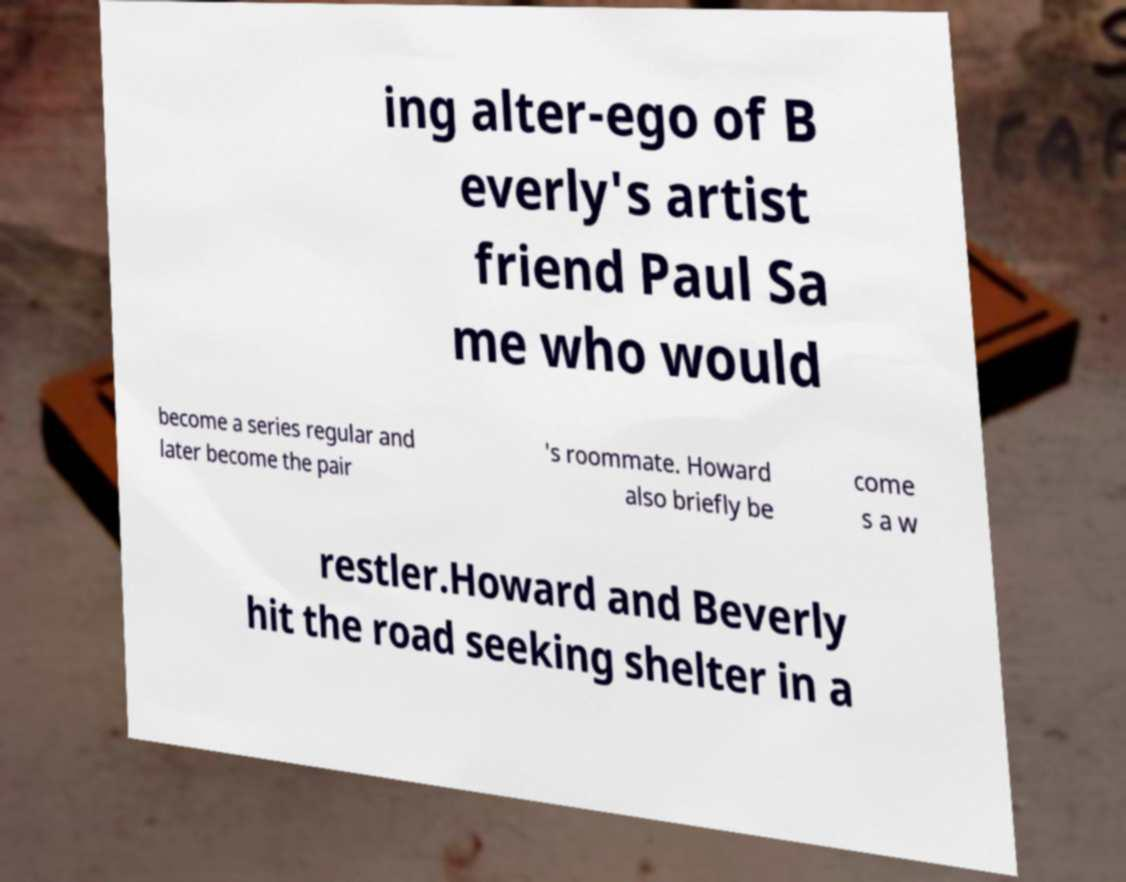Please read and relay the text visible in this image. What does it say? ing alter-ego of B everly's artist friend Paul Sa me who would become a series regular and later become the pair 's roommate. Howard also briefly be come s a w restler.Howard and Beverly hit the road seeking shelter in a 